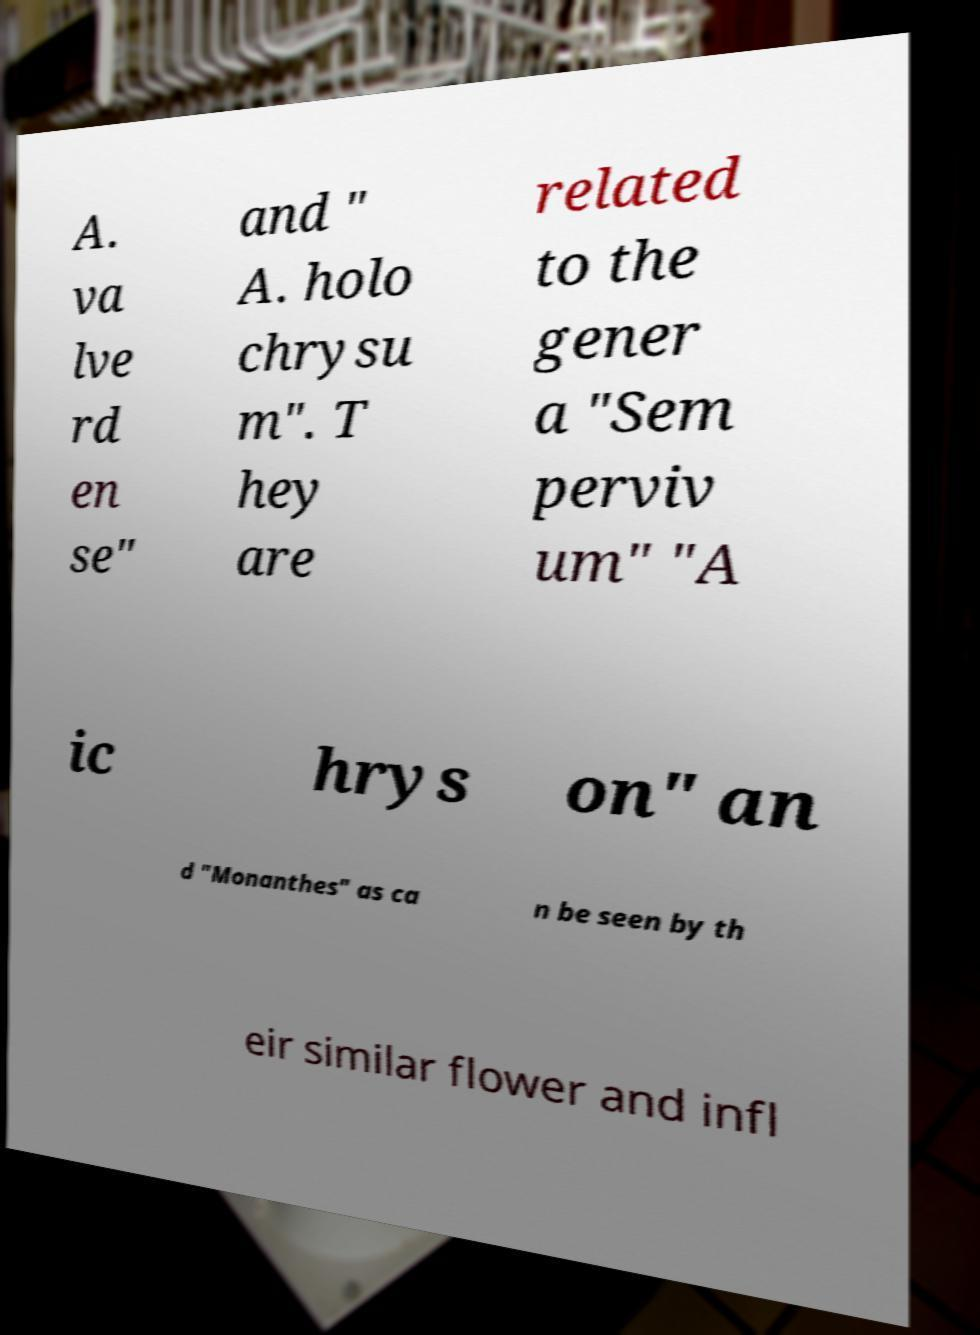What messages or text are displayed in this image? I need them in a readable, typed format. A. va lve rd en se" and " A. holo chrysu m". T hey are related to the gener a "Sem perviv um" "A ic hrys on" an d "Monanthes" as ca n be seen by th eir similar flower and infl 